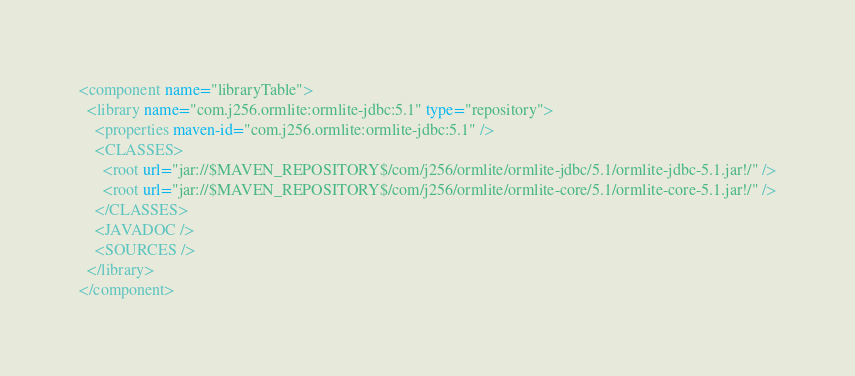Convert code to text. <code><loc_0><loc_0><loc_500><loc_500><_XML_><component name="libraryTable">
  <library name="com.j256.ormlite:ormlite-jdbc:5.1" type="repository">
    <properties maven-id="com.j256.ormlite:ormlite-jdbc:5.1" />
    <CLASSES>
      <root url="jar://$MAVEN_REPOSITORY$/com/j256/ormlite/ormlite-jdbc/5.1/ormlite-jdbc-5.1.jar!/" />
      <root url="jar://$MAVEN_REPOSITORY$/com/j256/ormlite/ormlite-core/5.1/ormlite-core-5.1.jar!/" />
    </CLASSES>
    <JAVADOC />
    <SOURCES />
  </library>
</component></code> 